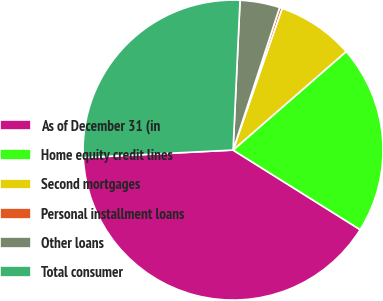Convert chart to OTSL. <chart><loc_0><loc_0><loc_500><loc_500><pie_chart><fcel>As of December 31 (in<fcel>Home equity credit lines<fcel>Second mortgages<fcel>Personal installment loans<fcel>Other loans<fcel>Total consumer<nl><fcel>40.3%<fcel>20.31%<fcel>8.29%<fcel>0.28%<fcel>4.28%<fcel>26.54%<nl></chart> 